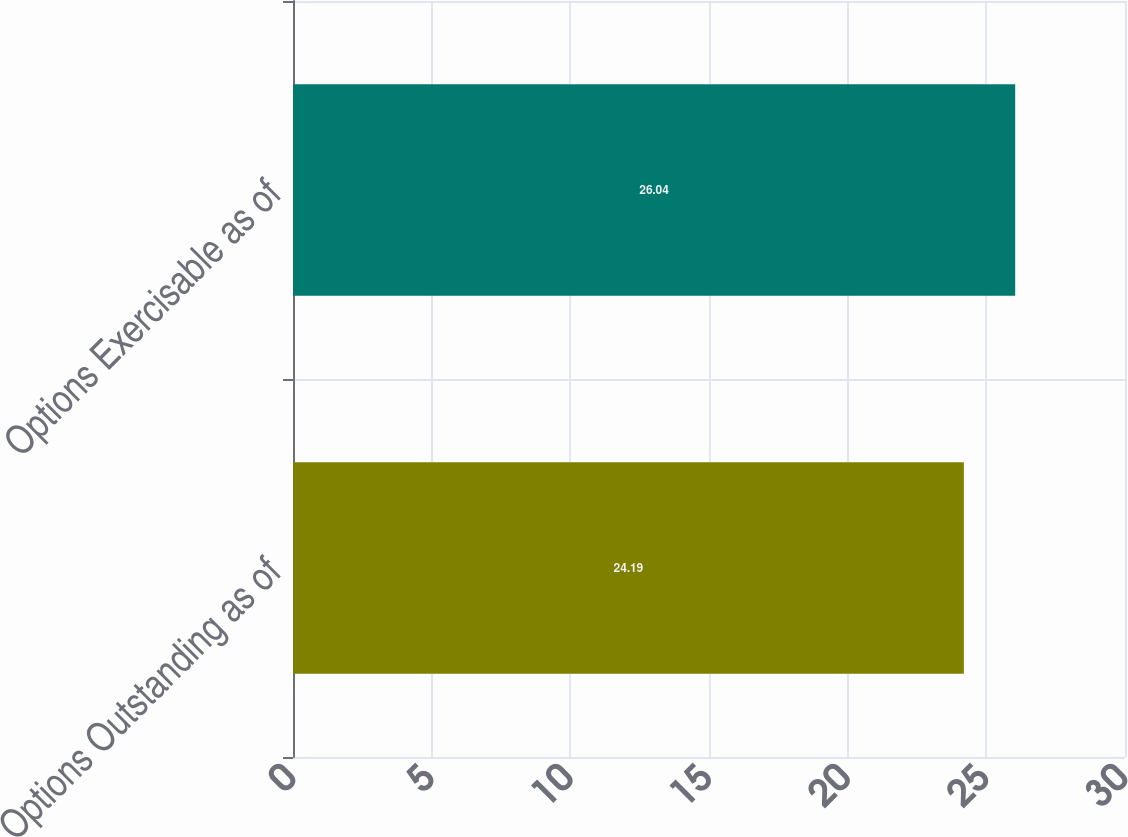Convert chart to OTSL. <chart><loc_0><loc_0><loc_500><loc_500><bar_chart><fcel>Options Outstanding as of<fcel>Options Exercisable as of<nl><fcel>24.19<fcel>26.04<nl></chart> 